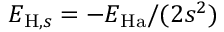<formula> <loc_0><loc_0><loc_500><loc_500>E _ { H , s } = - E _ { H a } / ( 2 s ^ { 2 } )</formula> 